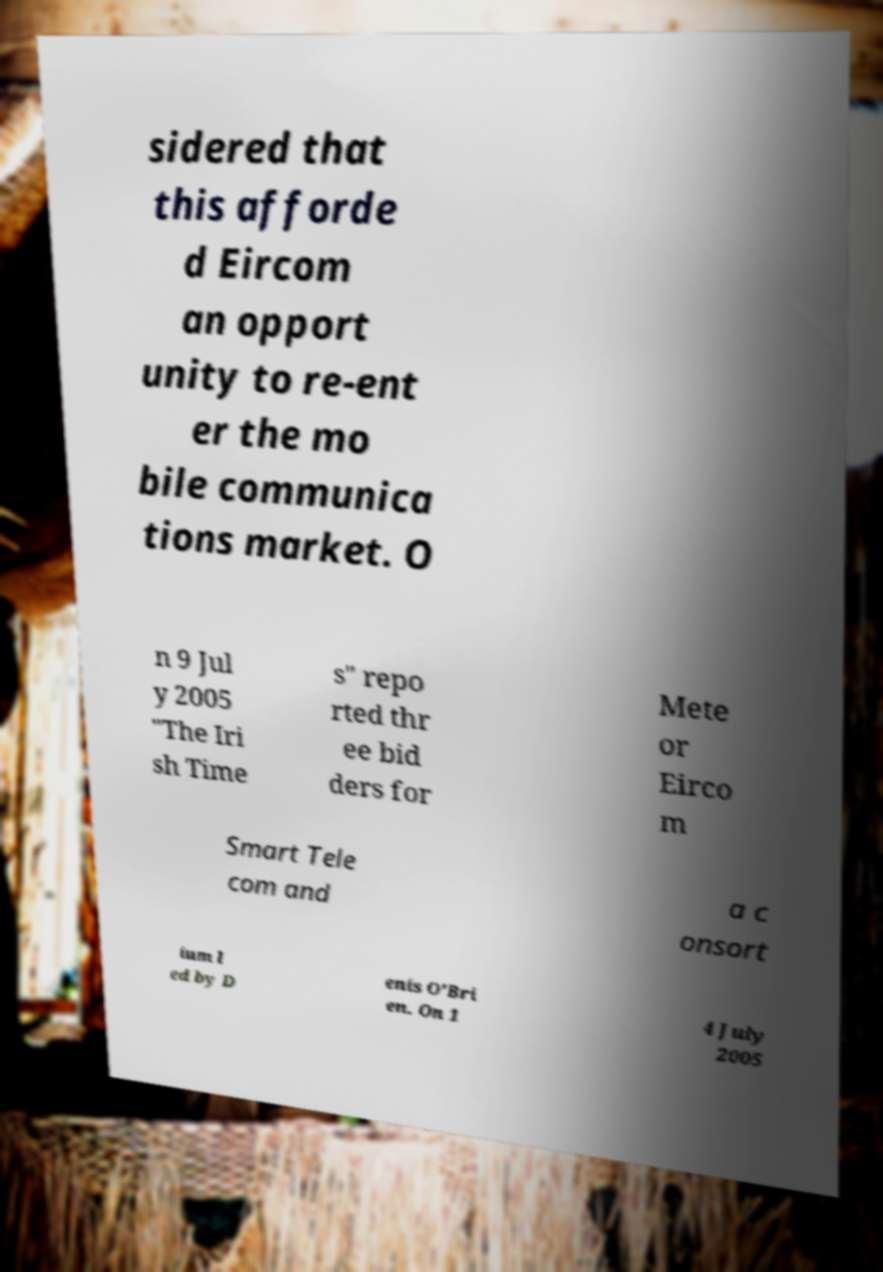Could you assist in decoding the text presented in this image and type it out clearly? sidered that this afforde d Eircom an opport unity to re-ent er the mo bile communica tions market. O n 9 Jul y 2005 "The Iri sh Time s" repo rted thr ee bid ders for Mete or Eirco m Smart Tele com and a c onsort ium l ed by D enis O'Bri en. On 1 4 July 2005 